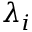Convert formula to latex. <formula><loc_0><loc_0><loc_500><loc_500>\lambda _ { i }</formula> 